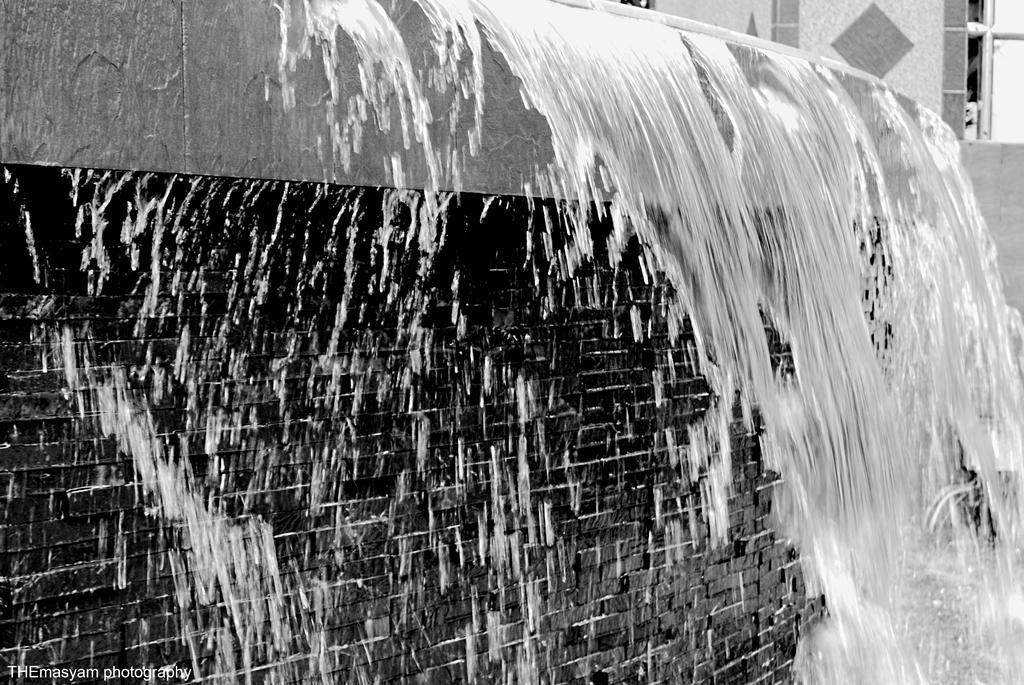In one or two sentences, can you explain what this image depicts? This image is taken outdoors. This image is a black and white image. In the background there is a wall. At the top right of the image there are two iron bars. In the middle of the image there is a wall and there is a fountain with water. 